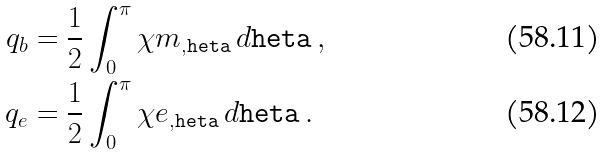Convert formula to latex. <formula><loc_0><loc_0><loc_500><loc_500>q _ { b } & = \frac { 1 } { 2 } \int _ { 0 } ^ { \pi } \chi m _ { , \tt h e t a } \, d \tt h e t a \, , \\ q _ { e } & = \frac { 1 } { 2 } \int _ { 0 } ^ { \pi } \chi e _ { , \tt h e t a } \, d \tt h e t a \, .</formula> 